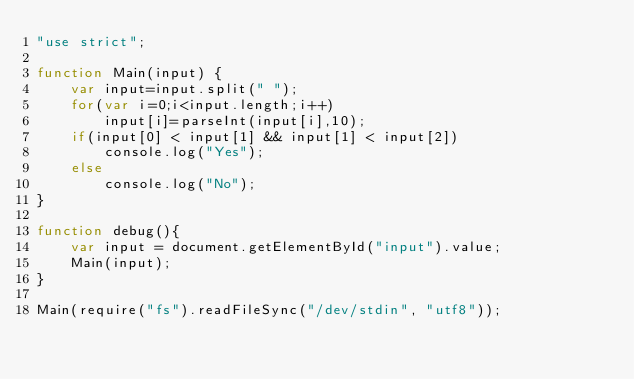Convert code to text. <code><loc_0><loc_0><loc_500><loc_500><_JavaScript_>"use strict";

function Main(input) {
    var input=input.split(" ");
    for(var i=0;i<input.length;i++)
        input[i]=parseInt(input[i],10);
    if(input[0] < input[1] && input[1] < input[2])
        console.log("Yes");
    else
        console.log("No");
}

function debug(){
	var input = document.getElementById("input").value;
	Main(input);
}

Main(require("fs").readFileSync("/dev/stdin", "utf8"));</code> 